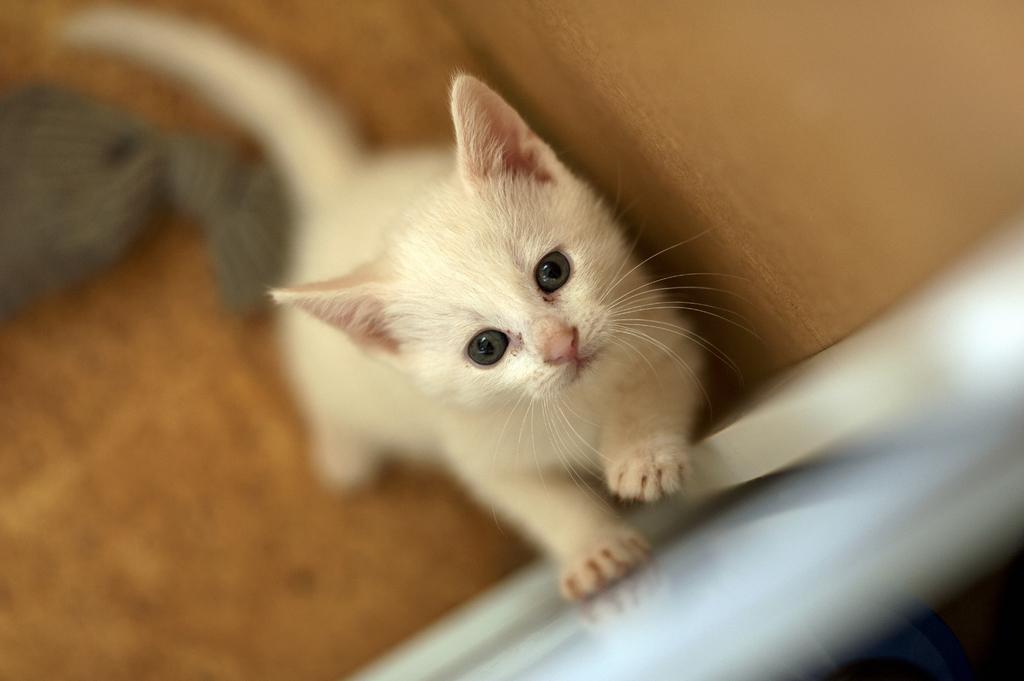How would you summarize this image in a sentence or two? On the right side there is a white color cat, standing on a leg and keeping one leg on another surface. And the background is blurred. 